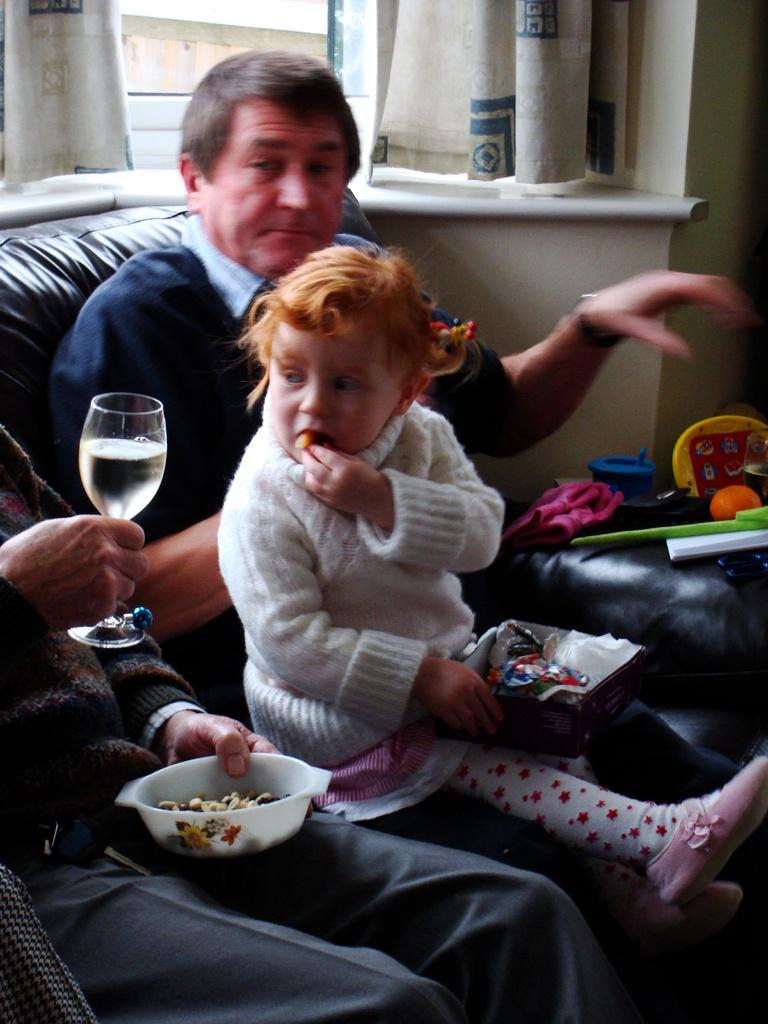What are the people in the image doing? There are people sitting on the sofa in the image. What is the man holding in his hand? The man is holding a wine glass and a bowl in his hand. What type of store can be seen in the background of the image? There is no store visible in the image; it only shows people sitting on a sofa. 